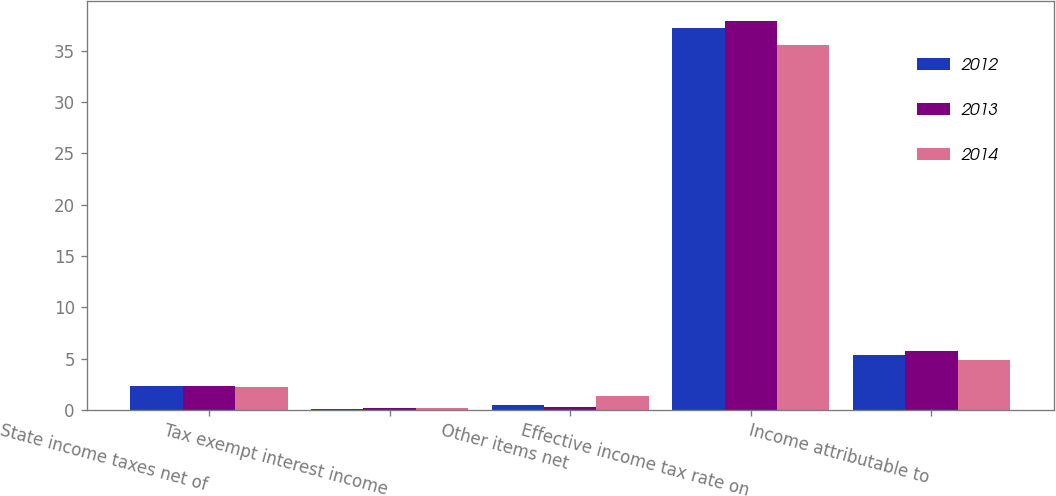Convert chart. <chart><loc_0><loc_0><loc_500><loc_500><stacked_bar_chart><ecel><fcel>State income taxes net of<fcel>Tax exempt interest income<fcel>Other items net<fcel>Effective income tax rate on<fcel>Income attributable to<nl><fcel>2012<fcel>2.3<fcel>0.1<fcel>0.5<fcel>37.2<fcel>5.4<nl><fcel>2013<fcel>2.3<fcel>0.2<fcel>0.3<fcel>37.9<fcel>5.7<nl><fcel>2014<fcel>2.2<fcel>0.2<fcel>1.4<fcel>35.6<fcel>4.9<nl></chart> 